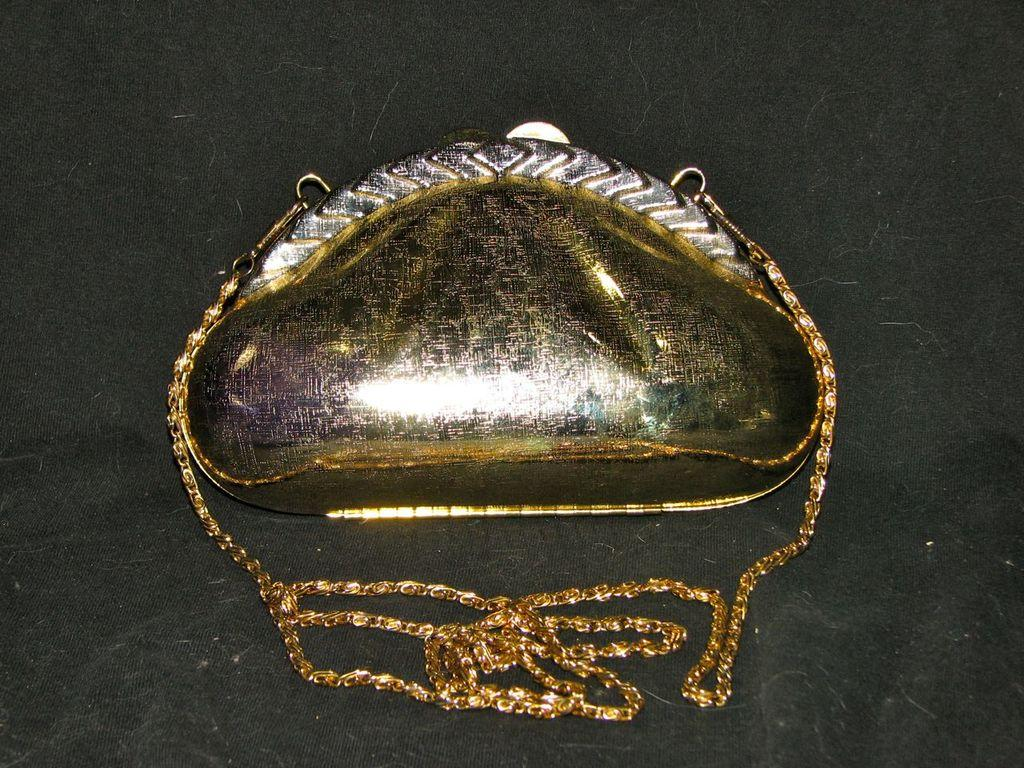What can be seen in the image? There is an object in the image. What is the object placed on? The object is placed on a black cloth. Is there anything else connected to the object? Yes, there is a golden chain attached to the object. What type of truck can be seen driving through the sink in the image? There is no truck or sink present in the image; it only features an object placed on a black cloth with a golden chain attached. How many rings are visible on the object in the image? There is no mention of rings in the image, so it cannot be determined how many, if any, are visible. 